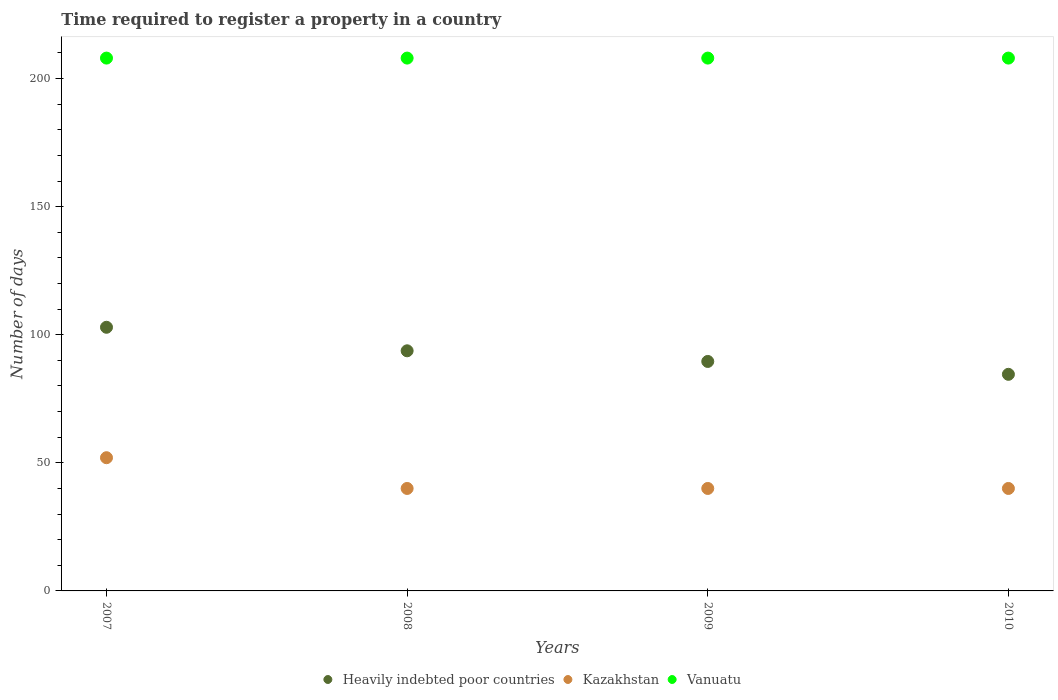What is the number of days required to register a property in Heavily indebted poor countries in 2009?
Offer a terse response. 89.58. Across all years, what is the maximum number of days required to register a property in Heavily indebted poor countries?
Provide a succinct answer. 102.92. What is the total number of days required to register a property in Vanuatu in the graph?
Make the answer very short. 832. What is the difference between the number of days required to register a property in Kazakhstan in 2008 and that in 2010?
Give a very brief answer. 0. What is the difference between the number of days required to register a property in Kazakhstan in 2010 and the number of days required to register a property in Vanuatu in 2008?
Keep it short and to the point. -168. What is the average number of days required to register a property in Heavily indebted poor countries per year?
Give a very brief answer. 92.7. In the year 2010, what is the difference between the number of days required to register a property in Heavily indebted poor countries and number of days required to register a property in Kazakhstan?
Provide a succinct answer. 44.55. In how many years, is the number of days required to register a property in Kazakhstan greater than 170 days?
Offer a very short reply. 0. What is the ratio of the number of days required to register a property in Vanuatu in 2007 to that in 2010?
Your answer should be compact. 1. Is the number of days required to register a property in Kazakhstan in 2009 less than that in 2010?
Your answer should be compact. No. Is the difference between the number of days required to register a property in Heavily indebted poor countries in 2007 and 2009 greater than the difference between the number of days required to register a property in Kazakhstan in 2007 and 2009?
Offer a very short reply. Yes. What is the difference between the highest and the second highest number of days required to register a property in Kazakhstan?
Your answer should be very brief. 12. What is the difference between the highest and the lowest number of days required to register a property in Heavily indebted poor countries?
Ensure brevity in your answer.  18.37. In how many years, is the number of days required to register a property in Vanuatu greater than the average number of days required to register a property in Vanuatu taken over all years?
Offer a terse response. 0. Is the sum of the number of days required to register a property in Heavily indebted poor countries in 2007 and 2010 greater than the maximum number of days required to register a property in Vanuatu across all years?
Provide a succinct answer. No. Is it the case that in every year, the sum of the number of days required to register a property in Heavily indebted poor countries and number of days required to register a property in Vanuatu  is greater than the number of days required to register a property in Kazakhstan?
Offer a terse response. Yes. Is the number of days required to register a property in Kazakhstan strictly less than the number of days required to register a property in Heavily indebted poor countries over the years?
Offer a very short reply. Yes. What is the difference between two consecutive major ticks on the Y-axis?
Ensure brevity in your answer.  50. How are the legend labels stacked?
Provide a short and direct response. Horizontal. What is the title of the graph?
Ensure brevity in your answer.  Time required to register a property in a country. Does "Senegal" appear as one of the legend labels in the graph?
Make the answer very short. No. What is the label or title of the Y-axis?
Ensure brevity in your answer.  Number of days. What is the Number of days of Heavily indebted poor countries in 2007?
Ensure brevity in your answer.  102.92. What is the Number of days in Vanuatu in 2007?
Give a very brief answer. 208. What is the Number of days of Heavily indebted poor countries in 2008?
Your answer should be very brief. 93.74. What is the Number of days in Kazakhstan in 2008?
Give a very brief answer. 40. What is the Number of days in Vanuatu in 2008?
Your answer should be compact. 208. What is the Number of days in Heavily indebted poor countries in 2009?
Your response must be concise. 89.58. What is the Number of days in Kazakhstan in 2009?
Give a very brief answer. 40. What is the Number of days in Vanuatu in 2009?
Provide a succinct answer. 208. What is the Number of days in Heavily indebted poor countries in 2010?
Offer a very short reply. 84.55. What is the Number of days in Vanuatu in 2010?
Provide a succinct answer. 208. Across all years, what is the maximum Number of days in Heavily indebted poor countries?
Provide a succinct answer. 102.92. Across all years, what is the maximum Number of days of Vanuatu?
Provide a short and direct response. 208. Across all years, what is the minimum Number of days of Heavily indebted poor countries?
Offer a very short reply. 84.55. Across all years, what is the minimum Number of days of Kazakhstan?
Give a very brief answer. 40. Across all years, what is the minimum Number of days of Vanuatu?
Provide a succinct answer. 208. What is the total Number of days of Heavily indebted poor countries in the graph?
Ensure brevity in your answer.  370.79. What is the total Number of days in Kazakhstan in the graph?
Provide a succinct answer. 172. What is the total Number of days in Vanuatu in the graph?
Your answer should be compact. 832. What is the difference between the Number of days in Heavily indebted poor countries in 2007 and that in 2008?
Make the answer very short. 9.18. What is the difference between the Number of days in Kazakhstan in 2007 and that in 2008?
Offer a very short reply. 12. What is the difference between the Number of days of Vanuatu in 2007 and that in 2008?
Give a very brief answer. 0. What is the difference between the Number of days in Heavily indebted poor countries in 2007 and that in 2009?
Provide a short and direct response. 13.34. What is the difference between the Number of days in Kazakhstan in 2007 and that in 2009?
Provide a succinct answer. 12. What is the difference between the Number of days of Vanuatu in 2007 and that in 2009?
Ensure brevity in your answer.  0. What is the difference between the Number of days in Heavily indebted poor countries in 2007 and that in 2010?
Ensure brevity in your answer.  18.37. What is the difference between the Number of days of Vanuatu in 2007 and that in 2010?
Make the answer very short. 0. What is the difference between the Number of days in Heavily indebted poor countries in 2008 and that in 2009?
Offer a terse response. 4.16. What is the difference between the Number of days of Kazakhstan in 2008 and that in 2009?
Ensure brevity in your answer.  0. What is the difference between the Number of days of Heavily indebted poor countries in 2008 and that in 2010?
Offer a terse response. 9.18. What is the difference between the Number of days in Vanuatu in 2008 and that in 2010?
Give a very brief answer. 0. What is the difference between the Number of days in Heavily indebted poor countries in 2009 and that in 2010?
Make the answer very short. 5.03. What is the difference between the Number of days in Kazakhstan in 2009 and that in 2010?
Ensure brevity in your answer.  0. What is the difference between the Number of days in Vanuatu in 2009 and that in 2010?
Provide a short and direct response. 0. What is the difference between the Number of days of Heavily indebted poor countries in 2007 and the Number of days of Kazakhstan in 2008?
Give a very brief answer. 62.92. What is the difference between the Number of days in Heavily indebted poor countries in 2007 and the Number of days in Vanuatu in 2008?
Keep it short and to the point. -105.08. What is the difference between the Number of days of Kazakhstan in 2007 and the Number of days of Vanuatu in 2008?
Ensure brevity in your answer.  -156. What is the difference between the Number of days of Heavily indebted poor countries in 2007 and the Number of days of Kazakhstan in 2009?
Offer a terse response. 62.92. What is the difference between the Number of days in Heavily indebted poor countries in 2007 and the Number of days in Vanuatu in 2009?
Your response must be concise. -105.08. What is the difference between the Number of days of Kazakhstan in 2007 and the Number of days of Vanuatu in 2009?
Make the answer very short. -156. What is the difference between the Number of days in Heavily indebted poor countries in 2007 and the Number of days in Kazakhstan in 2010?
Your answer should be compact. 62.92. What is the difference between the Number of days of Heavily indebted poor countries in 2007 and the Number of days of Vanuatu in 2010?
Your answer should be compact. -105.08. What is the difference between the Number of days in Kazakhstan in 2007 and the Number of days in Vanuatu in 2010?
Your answer should be very brief. -156. What is the difference between the Number of days in Heavily indebted poor countries in 2008 and the Number of days in Kazakhstan in 2009?
Give a very brief answer. 53.74. What is the difference between the Number of days in Heavily indebted poor countries in 2008 and the Number of days in Vanuatu in 2009?
Your response must be concise. -114.26. What is the difference between the Number of days of Kazakhstan in 2008 and the Number of days of Vanuatu in 2009?
Offer a very short reply. -168. What is the difference between the Number of days of Heavily indebted poor countries in 2008 and the Number of days of Kazakhstan in 2010?
Provide a short and direct response. 53.74. What is the difference between the Number of days of Heavily indebted poor countries in 2008 and the Number of days of Vanuatu in 2010?
Provide a short and direct response. -114.26. What is the difference between the Number of days of Kazakhstan in 2008 and the Number of days of Vanuatu in 2010?
Offer a very short reply. -168. What is the difference between the Number of days in Heavily indebted poor countries in 2009 and the Number of days in Kazakhstan in 2010?
Your answer should be very brief. 49.58. What is the difference between the Number of days of Heavily indebted poor countries in 2009 and the Number of days of Vanuatu in 2010?
Your response must be concise. -118.42. What is the difference between the Number of days in Kazakhstan in 2009 and the Number of days in Vanuatu in 2010?
Your answer should be compact. -168. What is the average Number of days of Heavily indebted poor countries per year?
Provide a succinct answer. 92.7. What is the average Number of days in Kazakhstan per year?
Give a very brief answer. 43. What is the average Number of days in Vanuatu per year?
Your response must be concise. 208. In the year 2007, what is the difference between the Number of days of Heavily indebted poor countries and Number of days of Kazakhstan?
Provide a succinct answer. 50.92. In the year 2007, what is the difference between the Number of days of Heavily indebted poor countries and Number of days of Vanuatu?
Make the answer very short. -105.08. In the year 2007, what is the difference between the Number of days of Kazakhstan and Number of days of Vanuatu?
Make the answer very short. -156. In the year 2008, what is the difference between the Number of days of Heavily indebted poor countries and Number of days of Kazakhstan?
Provide a succinct answer. 53.74. In the year 2008, what is the difference between the Number of days of Heavily indebted poor countries and Number of days of Vanuatu?
Your answer should be compact. -114.26. In the year 2008, what is the difference between the Number of days of Kazakhstan and Number of days of Vanuatu?
Your response must be concise. -168. In the year 2009, what is the difference between the Number of days in Heavily indebted poor countries and Number of days in Kazakhstan?
Provide a short and direct response. 49.58. In the year 2009, what is the difference between the Number of days in Heavily indebted poor countries and Number of days in Vanuatu?
Your answer should be compact. -118.42. In the year 2009, what is the difference between the Number of days of Kazakhstan and Number of days of Vanuatu?
Your response must be concise. -168. In the year 2010, what is the difference between the Number of days in Heavily indebted poor countries and Number of days in Kazakhstan?
Your answer should be very brief. 44.55. In the year 2010, what is the difference between the Number of days in Heavily indebted poor countries and Number of days in Vanuatu?
Keep it short and to the point. -123.45. In the year 2010, what is the difference between the Number of days in Kazakhstan and Number of days in Vanuatu?
Make the answer very short. -168. What is the ratio of the Number of days of Heavily indebted poor countries in 2007 to that in 2008?
Offer a terse response. 1.1. What is the ratio of the Number of days of Vanuatu in 2007 to that in 2008?
Give a very brief answer. 1. What is the ratio of the Number of days of Heavily indebted poor countries in 2007 to that in 2009?
Make the answer very short. 1.15. What is the ratio of the Number of days of Kazakhstan in 2007 to that in 2009?
Provide a succinct answer. 1.3. What is the ratio of the Number of days in Vanuatu in 2007 to that in 2009?
Provide a short and direct response. 1. What is the ratio of the Number of days in Heavily indebted poor countries in 2007 to that in 2010?
Provide a succinct answer. 1.22. What is the ratio of the Number of days in Heavily indebted poor countries in 2008 to that in 2009?
Give a very brief answer. 1.05. What is the ratio of the Number of days of Heavily indebted poor countries in 2008 to that in 2010?
Keep it short and to the point. 1.11. What is the ratio of the Number of days of Kazakhstan in 2008 to that in 2010?
Give a very brief answer. 1. What is the ratio of the Number of days in Heavily indebted poor countries in 2009 to that in 2010?
Provide a short and direct response. 1.06. What is the ratio of the Number of days in Kazakhstan in 2009 to that in 2010?
Provide a succinct answer. 1. What is the ratio of the Number of days of Vanuatu in 2009 to that in 2010?
Provide a succinct answer. 1. What is the difference between the highest and the second highest Number of days in Heavily indebted poor countries?
Ensure brevity in your answer.  9.18. What is the difference between the highest and the second highest Number of days in Kazakhstan?
Ensure brevity in your answer.  12. What is the difference between the highest and the second highest Number of days in Vanuatu?
Give a very brief answer. 0. What is the difference between the highest and the lowest Number of days of Heavily indebted poor countries?
Your answer should be compact. 18.37. What is the difference between the highest and the lowest Number of days of Vanuatu?
Offer a terse response. 0. 